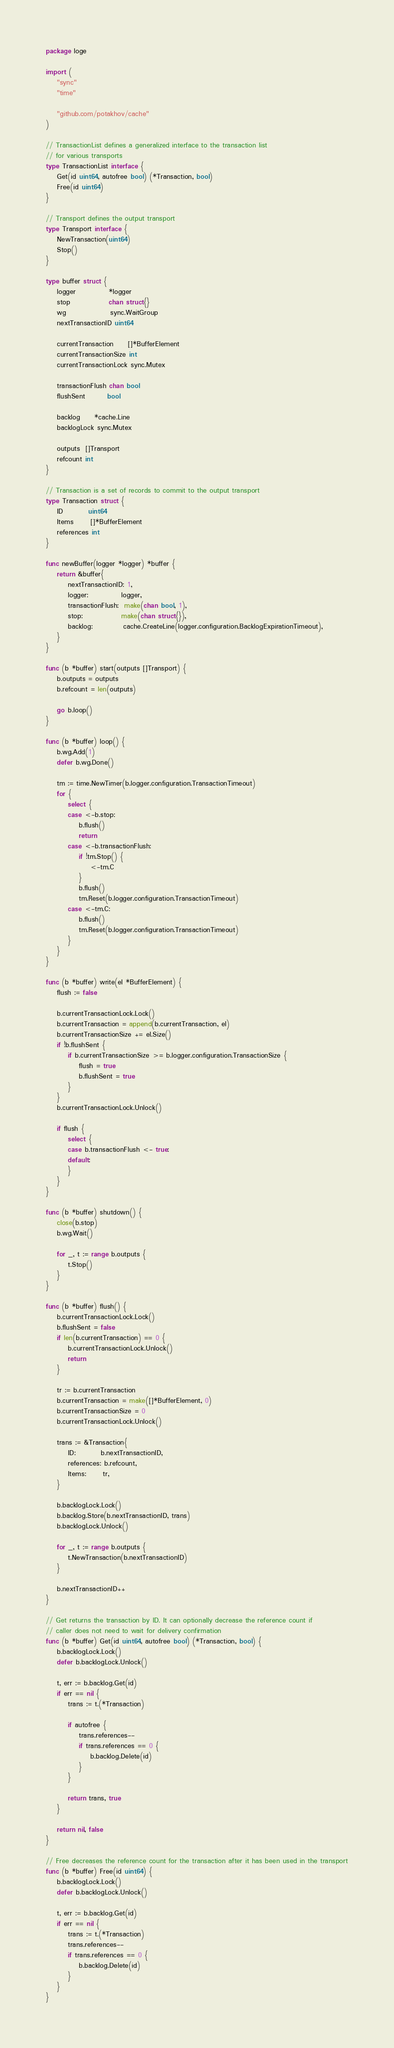<code> <loc_0><loc_0><loc_500><loc_500><_Go_>package loge

import (
	"sync"
	"time"

	"github.com/potakhov/cache"
)

// TransactionList defines a generalized interface to the transaction list
// for various transports
type TransactionList interface {
	Get(id uint64, autofree bool) (*Transaction, bool)
	Free(id uint64)
}

// Transport defines the output transport
type Transport interface {
	NewTransaction(uint64)
	Stop()
}

type buffer struct {
	logger            *logger
	stop              chan struct{}
	wg                sync.WaitGroup
	nextTransactionID uint64

	currentTransaction     []*BufferElement
	currentTransactionSize int
	currentTransactionLock sync.Mutex

	transactionFlush chan bool
	flushSent        bool

	backlog     *cache.Line
	backlogLock sync.Mutex

	outputs  []Transport
	refcount int
}

// Transaction is a set of records to commit to the output transport
type Transaction struct {
	ID         uint64
	Items      []*BufferElement
	references int
}

func newBuffer(logger *logger) *buffer {
	return &buffer{
		nextTransactionID: 1,
		logger:            logger,
		transactionFlush:  make(chan bool, 1),
		stop:              make(chan struct{}),
		backlog:           cache.CreateLine(logger.configuration.BacklogExpirationTimeout),
	}
}

func (b *buffer) start(outputs []Transport) {
	b.outputs = outputs
	b.refcount = len(outputs)

	go b.loop()
}

func (b *buffer) loop() {
	b.wg.Add(1)
	defer b.wg.Done()

	tm := time.NewTimer(b.logger.configuration.TransactionTimeout)
	for {
		select {
		case <-b.stop:
			b.flush()
			return
		case <-b.transactionFlush:
			if !tm.Stop() {
				<-tm.C
			}
			b.flush()
			tm.Reset(b.logger.configuration.TransactionTimeout)
		case <-tm.C:
			b.flush()
			tm.Reset(b.logger.configuration.TransactionTimeout)
		}
	}
}

func (b *buffer) write(el *BufferElement) {
	flush := false

	b.currentTransactionLock.Lock()
	b.currentTransaction = append(b.currentTransaction, el)
	b.currentTransactionSize += el.Size()
	if !b.flushSent {
		if b.currentTransactionSize >= b.logger.configuration.TransactionSize {
			flush = true
			b.flushSent = true
		}
	}
	b.currentTransactionLock.Unlock()

	if flush {
		select {
		case b.transactionFlush <- true:
		default:
		}
	}
}

func (b *buffer) shutdown() {
	close(b.stop)
	b.wg.Wait()

	for _, t := range b.outputs {
		t.Stop()
	}
}

func (b *buffer) flush() {
	b.currentTransactionLock.Lock()
	b.flushSent = false
	if len(b.currentTransaction) == 0 {
		b.currentTransactionLock.Unlock()
		return
	}

	tr := b.currentTransaction
	b.currentTransaction = make([]*BufferElement, 0)
	b.currentTransactionSize = 0
	b.currentTransactionLock.Unlock()

	trans := &Transaction{
		ID:         b.nextTransactionID,
		references: b.refcount,
		Items:      tr,
	}

	b.backlogLock.Lock()
	b.backlog.Store(b.nextTransactionID, trans)
	b.backlogLock.Unlock()

	for _, t := range b.outputs {
		t.NewTransaction(b.nextTransactionID)
	}

	b.nextTransactionID++
}

// Get returns the transaction by ID. It can optionally decrease the reference count if
// caller does not need to wait for delivery confirmation
func (b *buffer) Get(id uint64, autofree bool) (*Transaction, bool) {
	b.backlogLock.Lock()
	defer b.backlogLock.Unlock()

	t, err := b.backlog.Get(id)
	if err == nil {
		trans := t.(*Transaction)

		if autofree {
			trans.references--
			if trans.references == 0 {
				b.backlog.Delete(id)
			}
		}

		return trans, true
	}

	return nil, false
}

// Free decreases the reference count for the transaction after it has been used in the transport
func (b *buffer) Free(id uint64) {
	b.backlogLock.Lock()
	defer b.backlogLock.Unlock()

	t, err := b.backlog.Get(id)
	if err == nil {
		trans := t.(*Transaction)
		trans.references--
		if trans.references == 0 {
			b.backlog.Delete(id)
		}
	}
}
</code> 